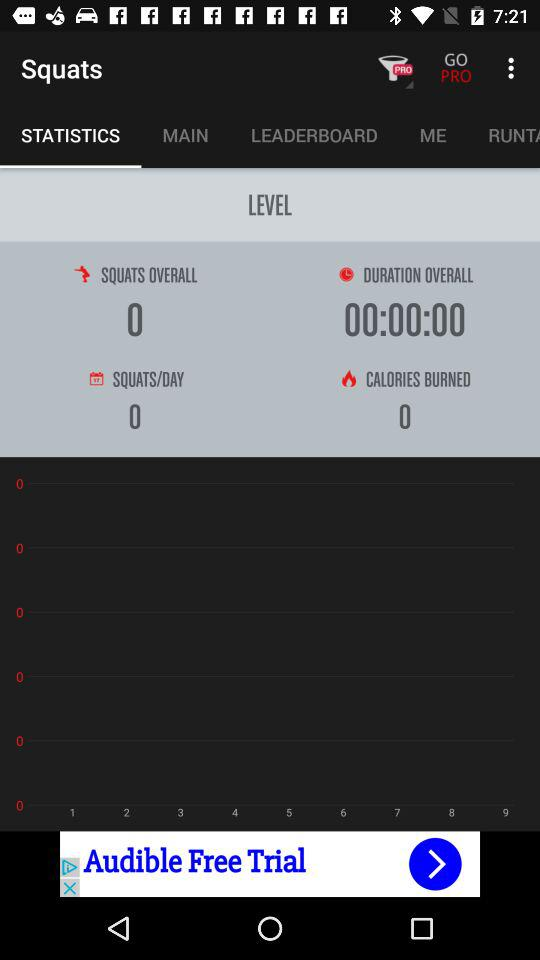What is the total number of squats shown in the application? The total number of squats shown in the application is 0. 